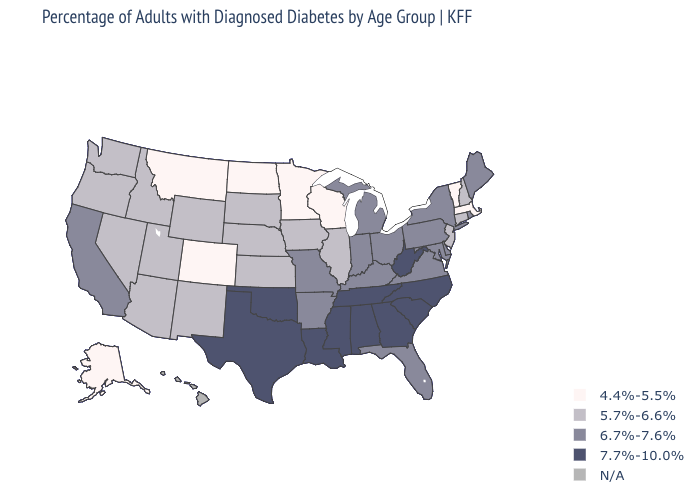What is the lowest value in the Northeast?
Answer briefly. 4.4%-5.5%. Name the states that have a value in the range 7.7%-10.0%?
Answer briefly. Alabama, Georgia, Louisiana, Mississippi, North Carolina, Oklahoma, South Carolina, Tennessee, Texas, West Virginia. Name the states that have a value in the range 6.7%-7.6%?
Give a very brief answer. Arkansas, California, Delaware, Florida, Indiana, Kentucky, Maine, Maryland, Michigan, Missouri, New York, Ohio, Pennsylvania, Rhode Island, Virginia. What is the value of Mississippi?
Quick response, please. 7.7%-10.0%. Which states have the lowest value in the USA?
Keep it brief. Alaska, Colorado, Massachusetts, Minnesota, Montana, North Dakota, Vermont, Wisconsin. Does Arkansas have the lowest value in the USA?
Be succinct. No. What is the highest value in states that border Oklahoma?
Short answer required. 7.7%-10.0%. What is the value of Missouri?
Concise answer only. 6.7%-7.6%. Does Kansas have the lowest value in the USA?
Write a very short answer. No. Name the states that have a value in the range 6.7%-7.6%?
Quick response, please. Arkansas, California, Delaware, Florida, Indiana, Kentucky, Maine, Maryland, Michigan, Missouri, New York, Ohio, Pennsylvania, Rhode Island, Virginia. Name the states that have a value in the range N/A?
Concise answer only. Hawaii. What is the lowest value in states that border Delaware?
Keep it brief. 5.7%-6.6%. What is the value of Tennessee?
Answer briefly. 7.7%-10.0%. What is the value of Maine?
Concise answer only. 6.7%-7.6%. Does the first symbol in the legend represent the smallest category?
Concise answer only. Yes. 